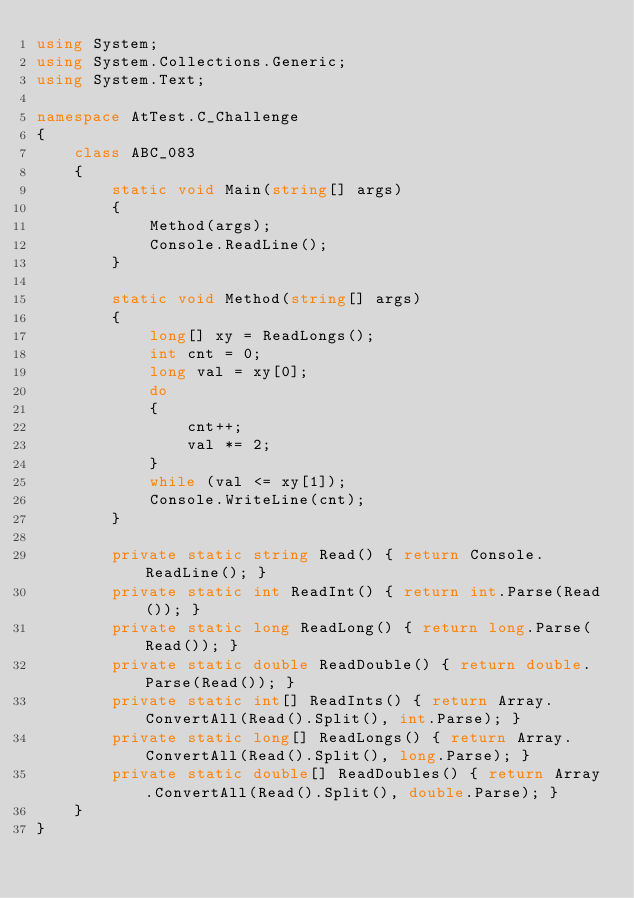Convert code to text. <code><loc_0><loc_0><loc_500><loc_500><_C#_>using System;
using System.Collections.Generic;
using System.Text;

namespace AtTest.C_Challenge
{
    class ABC_083
    {
        static void Main(string[] args)
        {
            Method(args);
            Console.ReadLine();
        }

        static void Method(string[] args)
        {
            long[] xy = ReadLongs();
            int cnt = 0;
            long val = xy[0];
            do
            {
                cnt++;
                val *= 2;
            }
            while (val <= xy[1]);
            Console.WriteLine(cnt);
        }

        private static string Read() { return Console.ReadLine(); }
        private static int ReadInt() { return int.Parse(Read()); }
        private static long ReadLong() { return long.Parse(Read()); }
        private static double ReadDouble() { return double.Parse(Read()); }
        private static int[] ReadInts() { return Array.ConvertAll(Read().Split(), int.Parse); }
        private static long[] ReadLongs() { return Array.ConvertAll(Read().Split(), long.Parse); }
        private static double[] ReadDoubles() { return Array.ConvertAll(Read().Split(), double.Parse); }
    }
}
</code> 